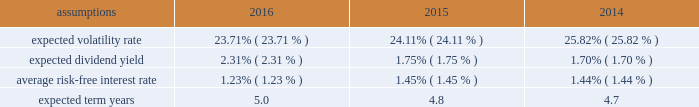Notes to the audited consolidated financial statements director stock compensation subplan eastman's 2016 director stock compensation subplan ( "directors' subplan" ) , a component of the 2012 omnibus plan , remains in effect until terminated by the board of directors or the earlier termination of thf e 2012 omnibus plan .
The directors' subplan provides for structured awards of restricted shares to non-employee members of the board of directors .
Restricted shares awarded under the directors' subplan are subject to the same terms and conditions of the 2012 omnibus plan .
The directors' subplan does not constitute a separate source of shares for grant of equity awards and all shares awarded are part of the 10 million shares authorized under the 2012 omnibus plan .
Shares of restricted stock are granted on the first day of a non-f employee director's initial term of service and shares of restricted stock are granted each year to each non-employee director on the date of the annual meeting of stockholders .
General the company is authorized by the board of directors under the 2012 omnibus plan tof provide awards to employees and non- employee members of the board of directors .
It has been the company's practice to issue new shares rather than treasury shares for equity awards that require settlement by the issuance of common stock and to withhold or accept back shares awarded to cover the related income tax obligations of employee participants .
Shares of unrestricted common stock owned by non-d employee directors are not eligible to be withheld or acquired to satisfy the withholding obligation related to their income taxes .
Aa shares of unrestricted common stock owned by specified senior management level employees are accepted by the company to pay the exercise price of stock options in accordance with the terms and conditions of their awards .
For 2016 , 2015 , and 2014 , total share-based compensation expense ( before tax ) of approximately $ 36 million , $ 36 million , and $ 28 million , respectively , was recognized in selling , general and administrative exd pense in the consolidated statements of earnings , comprehensive income and retained earnings for all share-based awards of which approximately $ 7 million , $ 7 million , and $ 4 million , respectively , related to stock options .
The compensation expense is recognized over the substantive vesting period , which may be a shorter time period than the stated vesting period for qualifying termination eligible employees as defined in the forms of award notice .
For 2016 , 2015 , and 2014 , approximately $ 2 million , $ 2 million , and $ 1 million , respectively , of stock option compensation expense was recognized due to qualifying termination eligibility preceding the requisite vesting period .
Stock option awards options have been granted on an annual basis to non-employee directors under the directors' subplan and predecessor plans and by the compensation and management development committee of the board of directors under the 2012 omnibus plan and predecessor plans to employees .
Option awards have an exercise price equal to the closing price of the company's stock on the date of grant .
The term of options is 10 years with vesting periods thf at vary up to three years .
Vesting usually occurs ratably over the vesting period or at the end of the vesting period .
The company utilizes the black scholes merton option valuation model which relies on certain assumptions to estimate an option's fair value .
The weighted average assumptions used in the determination of fair value for stock options awarded in 2016 , 2015 , and 2014 are provided in the table below: .

What was the average expected dividend yield from 2014 to 2016? 
Computations: ((((2.31% + 1.75%) + 1.70%) + 3) / 2)
Answer: 1.5288. 